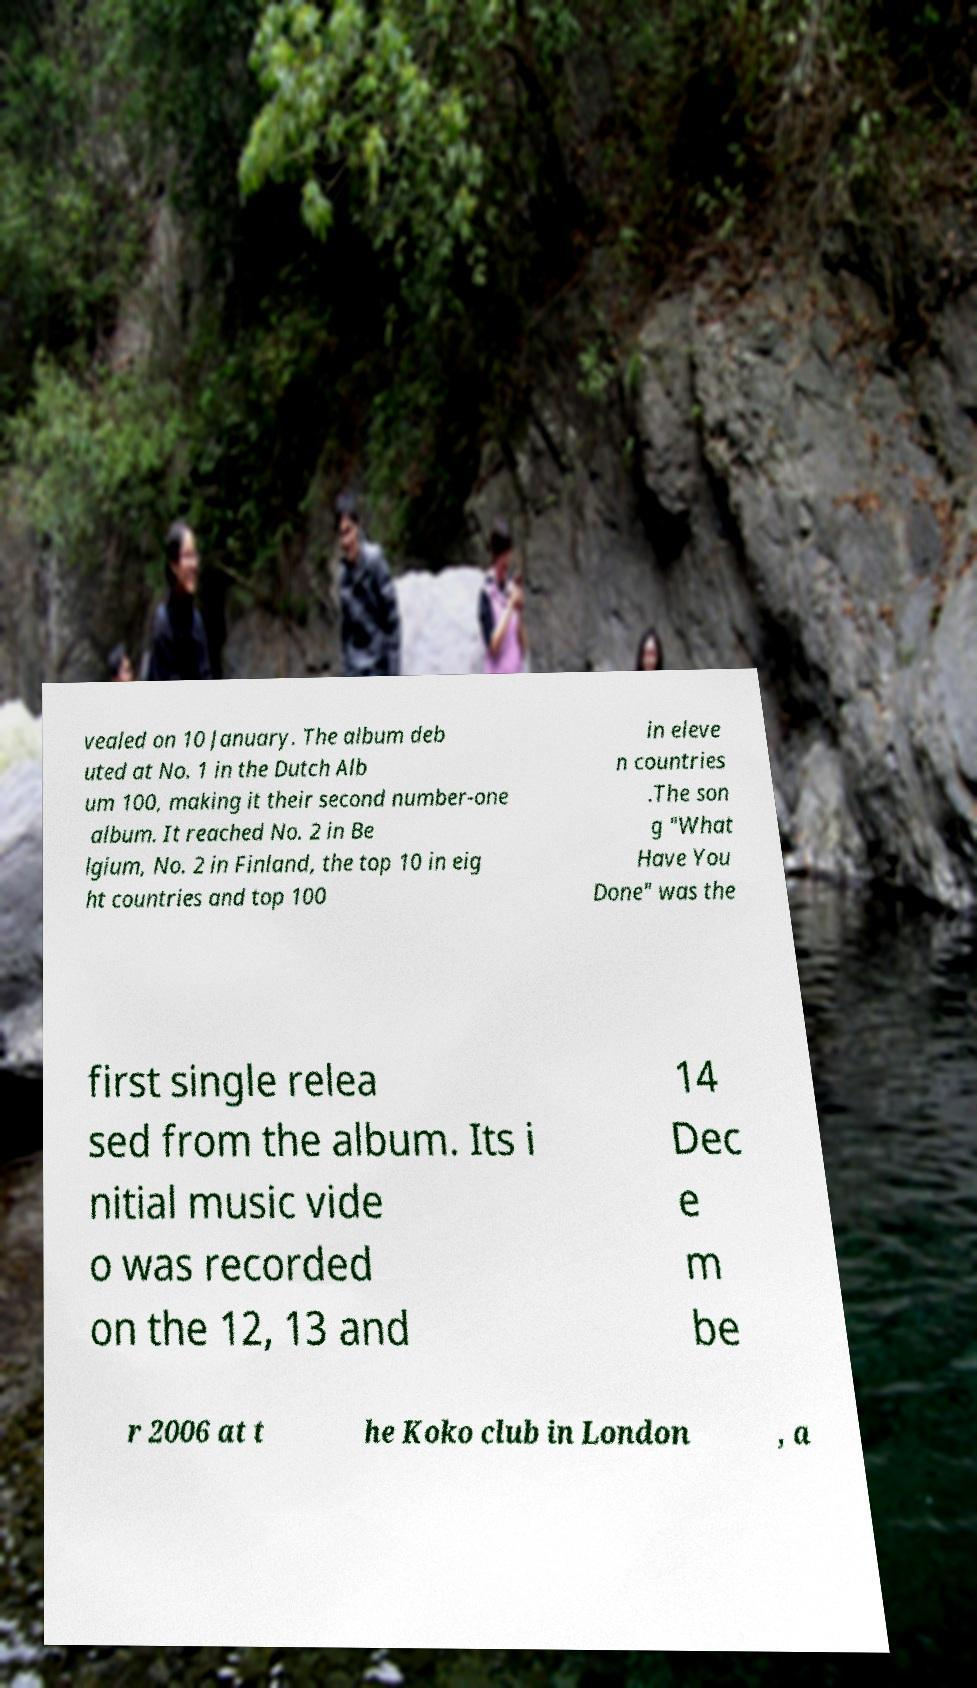Could you extract and type out the text from this image? vealed on 10 January. The album deb uted at No. 1 in the Dutch Alb um 100, making it their second number-one album. It reached No. 2 in Be lgium, No. 2 in Finland, the top 10 in eig ht countries and top 100 in eleve n countries .The son g "What Have You Done" was the first single relea sed from the album. Its i nitial music vide o was recorded on the 12, 13 and 14 Dec e m be r 2006 at t he Koko club in London , a 